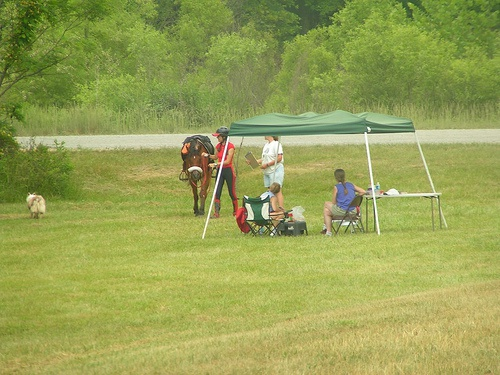Describe the objects in this image and their specific colors. I can see horse in darkgreen, olive, gray, maroon, and brown tones, people in darkgreen, olive, gray, and brown tones, people in darkgreen, gray, and tan tones, people in darkgreen, ivory, tan, beige, and darkgray tones, and chair in darkgreen and beige tones in this image. 